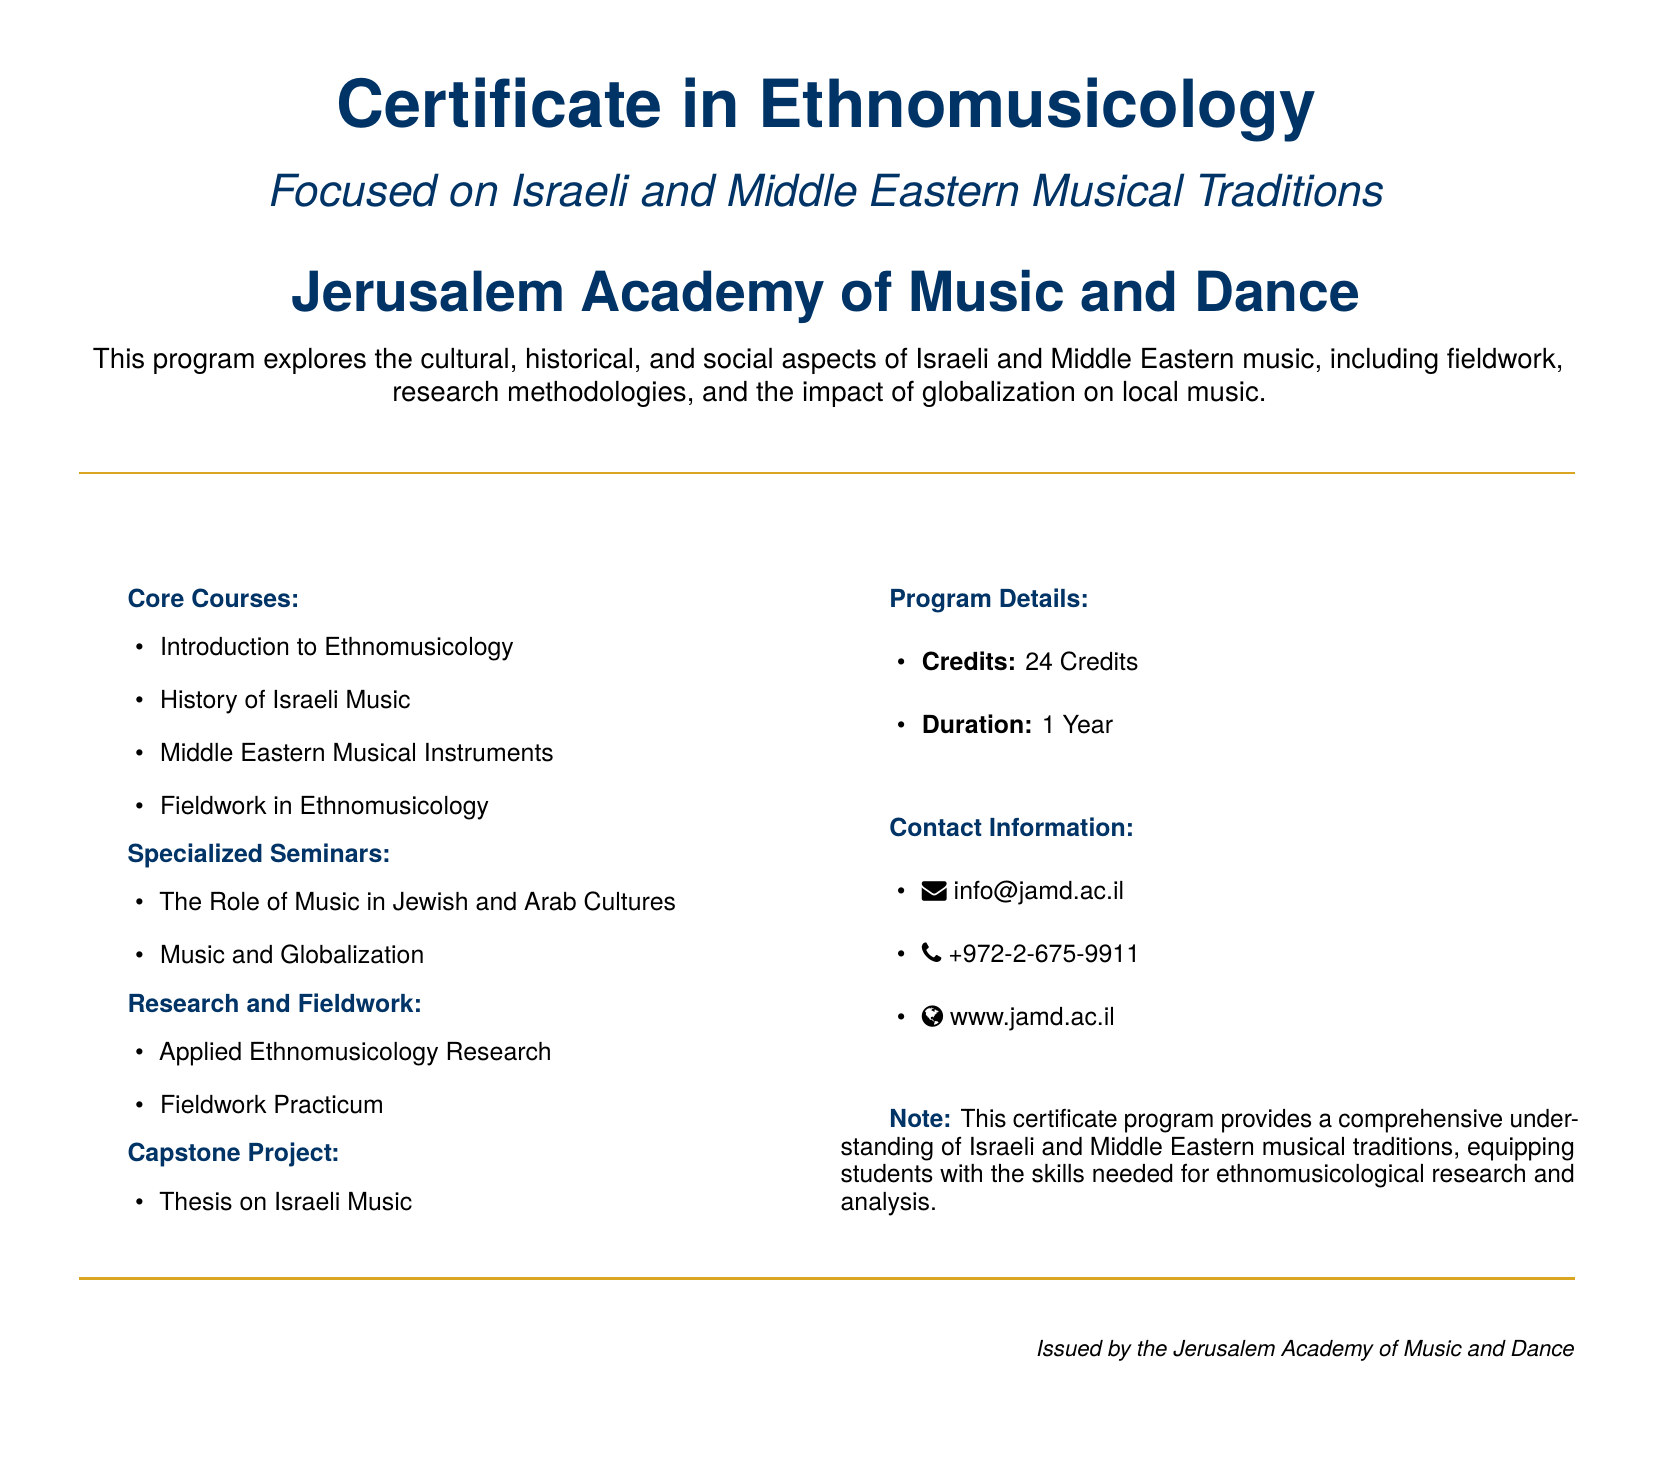What is the certificate program focused on? The program is focused on the study of Israeli and Middle Eastern musical traditions.
Answer: Israeli and Middle Eastern musical traditions How many credits is the program? The program details state that it requires a total of 24 credits.
Answer: 24 Credits What is the duration of the program? The duration of the program is listed as 1 year.
Answer: 1 Year What is one of the core courses offered? The core courses section includes several titles, one of which is History of Israeli Music.
Answer: History of Israeli Music What is the capstone project requirement? The document specifies that the capstone project consists of a thesis on Israeli music.
Answer: Thesis on Israeli Music Which seminar focuses on cultural aspects? The specialized seminars include a title that addresses this, specifically The Role of Music in Jewish and Arab Cultures.
Answer: The Role of Music in Jewish and Arab Cultures What type of research is emphasized in the program? The document mentions Applied Ethnomusicology Research as a critical component of the program.
Answer: Applied Ethnomusicology Research Where can you find more information about the program? The contact information section of the document includes a website for further inquiries at www.jamd.ac.il.
Answer: www.jamd.ac.il 